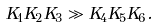Convert formula to latex. <formula><loc_0><loc_0><loc_500><loc_500>K _ { 1 } K _ { 2 } K _ { 3 } \gg K _ { 4 } K _ { 5 } K _ { 6 } .</formula> 